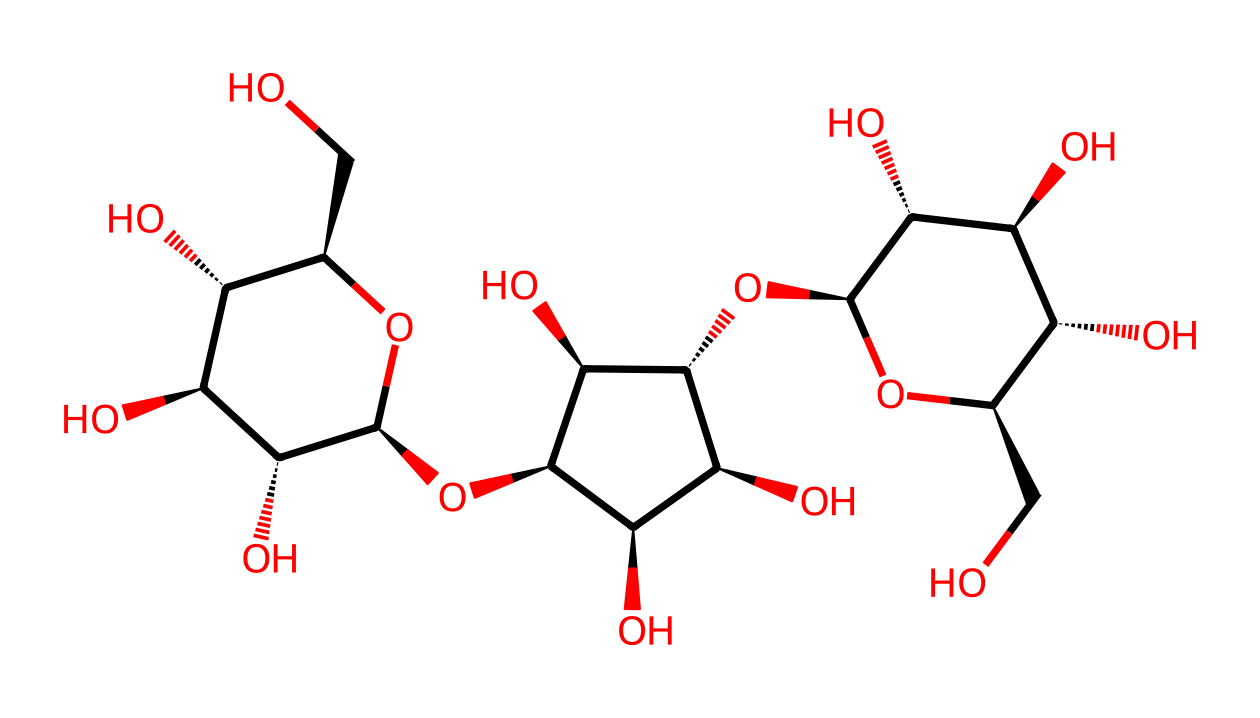What is the main building block of this chemical? The structure provided is a complex arrangement of glucose units, as indicated by the repeating patterns of hydroxyl groups and the cyclic forms characteristic of carbohydrates like cellulose.
Answer: glucose How many rings are present in this molecular structure? By examining the structure, there are multiple parts that show the cyclic nature of glucose, specifically looking for closed loops; in this case, there are three rings.
Answer: three What type of bonding is primarily present in this compound? In this structure, the predominant types of bonds include glycosidic linkages between the glucose units, indicated by their arrangement and connections, which are typical in polysaccharides.
Answer: glycosidic How does the presence of hydroxyl groups affect the properties of this nanomaterial? Hydroxyl groups are responsible for the hydrophilicity and reactivity of the polymer. Their presence leads to higher solubility in water and influences the mechanical properties, enhancing its eco-friendly characteristics.
Answer: hydrophilicity What is the molecular weight estimation of this compound? To estimate the molecular weight, one can count the number of carbon, hydrogen, and oxygen atoms and apply the appropriate atomic weights; typically, this results in a molecular weight around several hundred g/mol—for this specific compound, it's around 400 g/mol.
Answer: approximately 400 g/mol How does the structure contribute to the durability of the drumsticks? The interconnected networks of cellulose chains with extensive hydrogen bonding confer tensile strength and flexibility, which are essential for durable drumsticks capable of withstanding repeated impacts.
Answer: tensile strength 